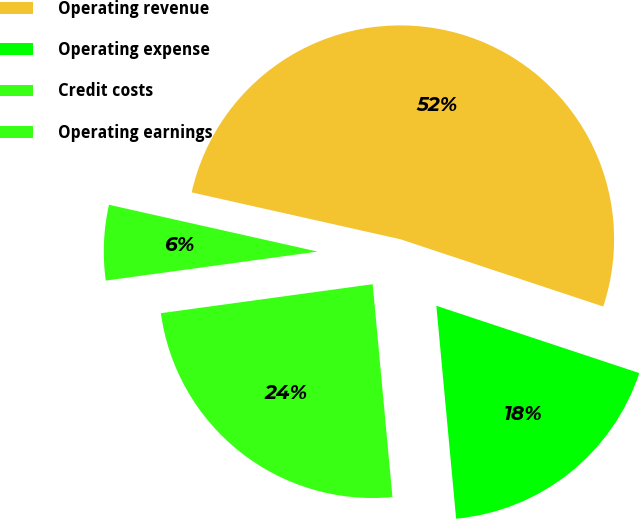Convert chart to OTSL. <chart><loc_0><loc_0><loc_500><loc_500><pie_chart><fcel>Operating revenue<fcel>Operating expense<fcel>Credit costs<fcel>Operating earnings<nl><fcel>51.58%<fcel>18.43%<fcel>24.31%<fcel>5.68%<nl></chart> 